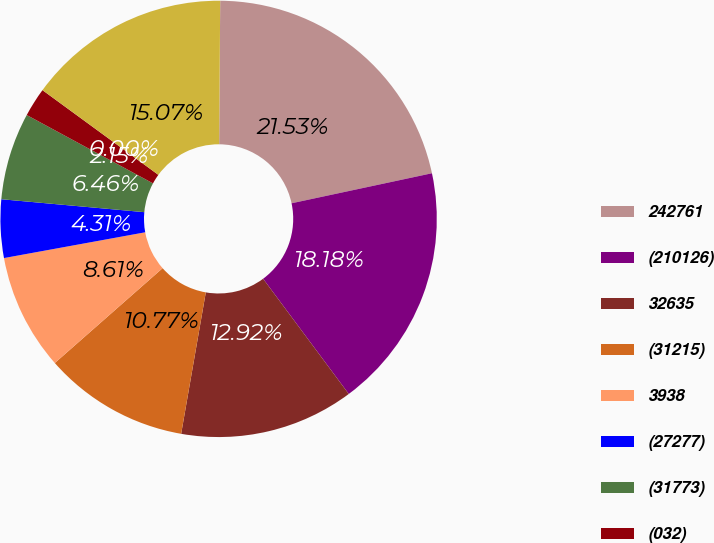Convert chart to OTSL. <chart><loc_0><loc_0><loc_500><loc_500><pie_chart><fcel>242761<fcel>(210126)<fcel>32635<fcel>(31215)<fcel>3938<fcel>(27277)<fcel>(31773)<fcel>(032)<fcel>(027)<fcel>117320<nl><fcel>21.53%<fcel>18.18%<fcel>12.92%<fcel>10.77%<fcel>8.61%<fcel>4.31%<fcel>6.46%<fcel>2.15%<fcel>0.0%<fcel>15.07%<nl></chart> 